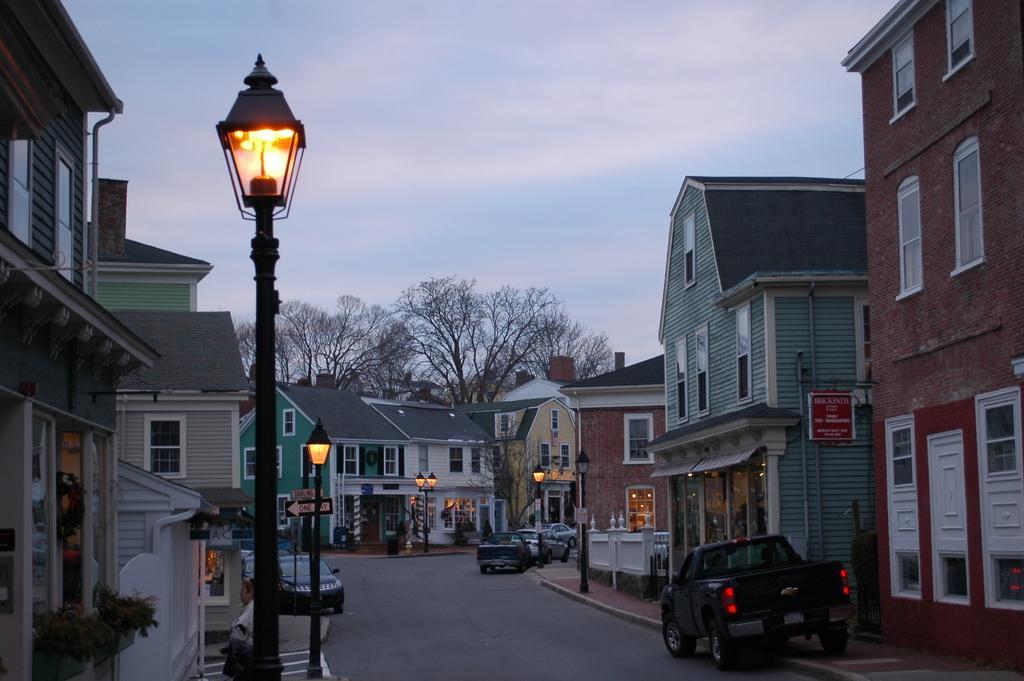How would you summarize this image in a sentence or two? This is an outside view. At the bottom of the image there are few vehicles on the road. On both sides of the road, I can see the buildings and light poles. In the background there are trees. At the top of the image I can see the sky. At the bottom there is a person standing facing towards the left side. 